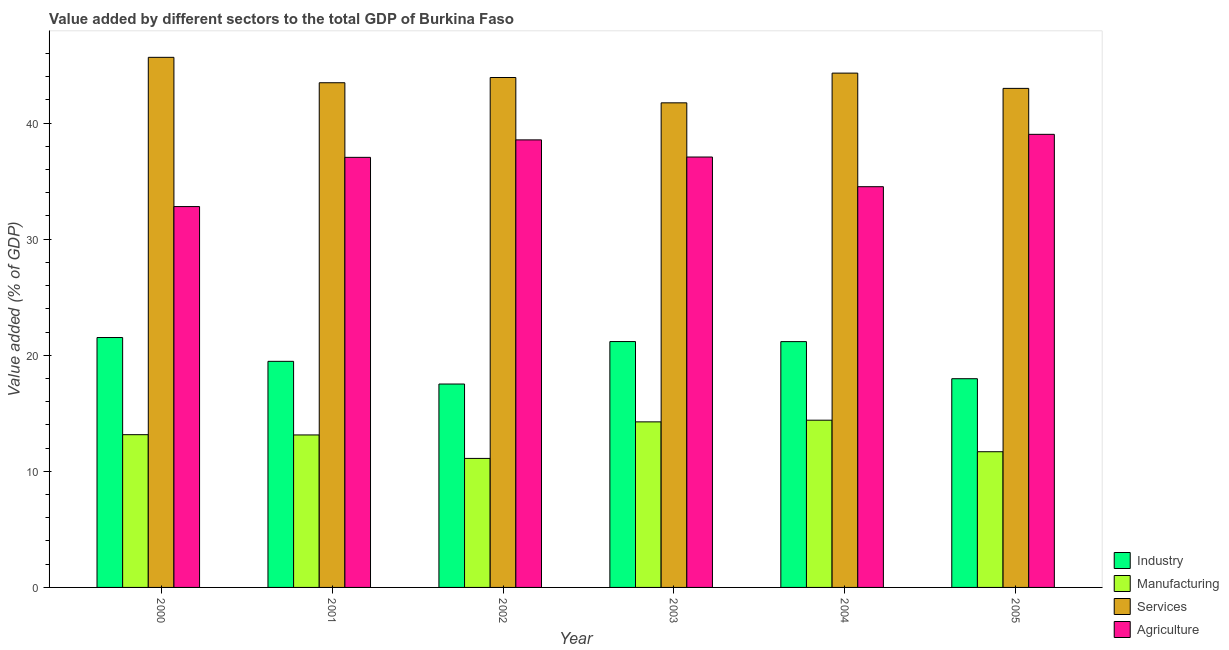Are the number of bars per tick equal to the number of legend labels?
Keep it short and to the point. Yes. How many bars are there on the 2nd tick from the left?
Keep it short and to the point. 4. What is the label of the 3rd group of bars from the left?
Your response must be concise. 2002. What is the value added by industrial sector in 2000?
Provide a short and direct response. 21.53. Across all years, what is the maximum value added by agricultural sector?
Give a very brief answer. 39.03. Across all years, what is the minimum value added by services sector?
Your response must be concise. 41.74. In which year was the value added by manufacturing sector maximum?
Offer a very short reply. 2004. In which year was the value added by services sector minimum?
Your response must be concise. 2003. What is the total value added by manufacturing sector in the graph?
Offer a terse response. 77.76. What is the difference between the value added by manufacturing sector in 2002 and that in 2004?
Give a very brief answer. -3.29. What is the difference between the value added by industrial sector in 2005 and the value added by agricultural sector in 2000?
Your answer should be very brief. -3.55. What is the average value added by agricultural sector per year?
Your response must be concise. 36.51. What is the ratio of the value added by industrial sector in 2004 to that in 2005?
Keep it short and to the point. 1.18. What is the difference between the highest and the second highest value added by industrial sector?
Provide a short and direct response. 0.35. What is the difference between the highest and the lowest value added by services sector?
Your response must be concise. 3.92. In how many years, is the value added by agricultural sector greater than the average value added by agricultural sector taken over all years?
Your answer should be compact. 4. Is the sum of the value added by services sector in 2001 and 2003 greater than the maximum value added by manufacturing sector across all years?
Provide a succinct answer. Yes. Is it the case that in every year, the sum of the value added by services sector and value added by agricultural sector is greater than the sum of value added by manufacturing sector and value added by industrial sector?
Keep it short and to the point. Yes. What does the 1st bar from the left in 2000 represents?
Your answer should be compact. Industry. What does the 1st bar from the right in 2000 represents?
Offer a very short reply. Agriculture. How many bars are there?
Make the answer very short. 24. How many years are there in the graph?
Provide a succinct answer. 6. Does the graph contain any zero values?
Offer a terse response. No. Where does the legend appear in the graph?
Your response must be concise. Bottom right. How many legend labels are there?
Provide a short and direct response. 4. What is the title of the graph?
Provide a succinct answer. Value added by different sectors to the total GDP of Burkina Faso. Does "International Monetary Fund" appear as one of the legend labels in the graph?
Keep it short and to the point. No. What is the label or title of the Y-axis?
Provide a succinct answer. Value added (% of GDP). What is the Value added (% of GDP) of Industry in 2000?
Your response must be concise. 21.53. What is the Value added (% of GDP) of Manufacturing in 2000?
Ensure brevity in your answer.  13.16. What is the Value added (% of GDP) in Services in 2000?
Your response must be concise. 45.66. What is the Value added (% of GDP) in Agriculture in 2000?
Ensure brevity in your answer.  32.81. What is the Value added (% of GDP) of Industry in 2001?
Offer a very short reply. 19.48. What is the Value added (% of GDP) in Manufacturing in 2001?
Keep it short and to the point. 13.13. What is the Value added (% of GDP) of Services in 2001?
Your answer should be compact. 43.47. What is the Value added (% of GDP) in Agriculture in 2001?
Provide a succinct answer. 37.05. What is the Value added (% of GDP) of Industry in 2002?
Offer a terse response. 17.52. What is the Value added (% of GDP) in Manufacturing in 2002?
Ensure brevity in your answer.  11.11. What is the Value added (% of GDP) in Services in 2002?
Offer a very short reply. 43.93. What is the Value added (% of GDP) in Agriculture in 2002?
Provide a succinct answer. 38.55. What is the Value added (% of GDP) of Industry in 2003?
Ensure brevity in your answer.  21.18. What is the Value added (% of GDP) of Manufacturing in 2003?
Offer a terse response. 14.26. What is the Value added (% of GDP) of Services in 2003?
Offer a terse response. 41.74. What is the Value added (% of GDP) of Agriculture in 2003?
Provide a short and direct response. 37.08. What is the Value added (% of GDP) of Industry in 2004?
Provide a short and direct response. 21.18. What is the Value added (% of GDP) in Manufacturing in 2004?
Your answer should be very brief. 14.41. What is the Value added (% of GDP) of Services in 2004?
Give a very brief answer. 44.3. What is the Value added (% of GDP) in Agriculture in 2004?
Your answer should be very brief. 34.52. What is the Value added (% of GDP) of Industry in 2005?
Your answer should be compact. 17.98. What is the Value added (% of GDP) of Manufacturing in 2005?
Your answer should be compact. 11.69. What is the Value added (% of GDP) in Services in 2005?
Your answer should be very brief. 42.99. What is the Value added (% of GDP) in Agriculture in 2005?
Your answer should be compact. 39.03. Across all years, what is the maximum Value added (% of GDP) of Industry?
Provide a short and direct response. 21.53. Across all years, what is the maximum Value added (% of GDP) of Manufacturing?
Ensure brevity in your answer.  14.41. Across all years, what is the maximum Value added (% of GDP) in Services?
Keep it short and to the point. 45.66. Across all years, what is the maximum Value added (% of GDP) in Agriculture?
Offer a very short reply. 39.03. Across all years, what is the minimum Value added (% of GDP) in Industry?
Provide a succinct answer. 17.52. Across all years, what is the minimum Value added (% of GDP) in Manufacturing?
Provide a short and direct response. 11.11. Across all years, what is the minimum Value added (% of GDP) in Services?
Make the answer very short. 41.74. Across all years, what is the minimum Value added (% of GDP) of Agriculture?
Provide a succinct answer. 32.81. What is the total Value added (% of GDP) in Industry in the graph?
Provide a succinct answer. 118.86. What is the total Value added (% of GDP) of Manufacturing in the graph?
Offer a very short reply. 77.76. What is the total Value added (% of GDP) in Services in the graph?
Your answer should be very brief. 262.1. What is the total Value added (% of GDP) in Agriculture in the graph?
Provide a succinct answer. 219.04. What is the difference between the Value added (% of GDP) of Industry in 2000 and that in 2001?
Keep it short and to the point. 2.05. What is the difference between the Value added (% of GDP) in Manufacturing in 2000 and that in 2001?
Keep it short and to the point. 0.02. What is the difference between the Value added (% of GDP) of Services in 2000 and that in 2001?
Your response must be concise. 2.19. What is the difference between the Value added (% of GDP) of Agriculture in 2000 and that in 2001?
Your answer should be very brief. -4.24. What is the difference between the Value added (% of GDP) in Industry in 2000 and that in 2002?
Make the answer very short. 4.01. What is the difference between the Value added (% of GDP) of Manufacturing in 2000 and that in 2002?
Give a very brief answer. 2.05. What is the difference between the Value added (% of GDP) in Services in 2000 and that in 2002?
Offer a terse response. 1.74. What is the difference between the Value added (% of GDP) of Agriculture in 2000 and that in 2002?
Ensure brevity in your answer.  -5.74. What is the difference between the Value added (% of GDP) of Industry in 2000 and that in 2003?
Provide a succinct answer. 0.35. What is the difference between the Value added (% of GDP) in Manufacturing in 2000 and that in 2003?
Offer a terse response. -1.1. What is the difference between the Value added (% of GDP) of Services in 2000 and that in 2003?
Ensure brevity in your answer.  3.92. What is the difference between the Value added (% of GDP) in Agriculture in 2000 and that in 2003?
Offer a terse response. -4.27. What is the difference between the Value added (% of GDP) in Industry in 2000 and that in 2004?
Provide a short and direct response. 0.35. What is the difference between the Value added (% of GDP) in Manufacturing in 2000 and that in 2004?
Your response must be concise. -1.25. What is the difference between the Value added (% of GDP) of Services in 2000 and that in 2004?
Provide a succinct answer. 1.36. What is the difference between the Value added (% of GDP) in Agriculture in 2000 and that in 2004?
Your response must be concise. -1.71. What is the difference between the Value added (% of GDP) in Industry in 2000 and that in 2005?
Provide a succinct answer. 3.55. What is the difference between the Value added (% of GDP) in Manufacturing in 2000 and that in 2005?
Keep it short and to the point. 1.47. What is the difference between the Value added (% of GDP) of Services in 2000 and that in 2005?
Your answer should be compact. 2.67. What is the difference between the Value added (% of GDP) of Agriculture in 2000 and that in 2005?
Make the answer very short. -6.22. What is the difference between the Value added (% of GDP) of Industry in 2001 and that in 2002?
Your response must be concise. 1.95. What is the difference between the Value added (% of GDP) of Manufacturing in 2001 and that in 2002?
Provide a succinct answer. 2.02. What is the difference between the Value added (% of GDP) in Services in 2001 and that in 2002?
Ensure brevity in your answer.  -0.45. What is the difference between the Value added (% of GDP) of Agriculture in 2001 and that in 2002?
Your answer should be very brief. -1.5. What is the difference between the Value added (% of GDP) of Industry in 2001 and that in 2003?
Give a very brief answer. -1.7. What is the difference between the Value added (% of GDP) in Manufacturing in 2001 and that in 2003?
Your answer should be compact. -1.13. What is the difference between the Value added (% of GDP) of Services in 2001 and that in 2003?
Provide a succinct answer. 1.73. What is the difference between the Value added (% of GDP) of Agriculture in 2001 and that in 2003?
Provide a succinct answer. -0.03. What is the difference between the Value added (% of GDP) of Industry in 2001 and that in 2004?
Provide a short and direct response. -1.7. What is the difference between the Value added (% of GDP) of Manufacturing in 2001 and that in 2004?
Offer a very short reply. -1.27. What is the difference between the Value added (% of GDP) in Services in 2001 and that in 2004?
Your response must be concise. -0.83. What is the difference between the Value added (% of GDP) in Agriculture in 2001 and that in 2004?
Provide a succinct answer. 2.53. What is the difference between the Value added (% of GDP) in Industry in 2001 and that in 2005?
Keep it short and to the point. 1.5. What is the difference between the Value added (% of GDP) of Manufacturing in 2001 and that in 2005?
Your answer should be compact. 1.45. What is the difference between the Value added (% of GDP) of Services in 2001 and that in 2005?
Keep it short and to the point. 0.49. What is the difference between the Value added (% of GDP) of Agriculture in 2001 and that in 2005?
Ensure brevity in your answer.  -1.98. What is the difference between the Value added (% of GDP) of Industry in 2002 and that in 2003?
Ensure brevity in your answer.  -3.66. What is the difference between the Value added (% of GDP) in Manufacturing in 2002 and that in 2003?
Provide a short and direct response. -3.15. What is the difference between the Value added (% of GDP) in Services in 2002 and that in 2003?
Offer a very short reply. 2.18. What is the difference between the Value added (% of GDP) in Agriculture in 2002 and that in 2003?
Your response must be concise. 1.48. What is the difference between the Value added (% of GDP) of Industry in 2002 and that in 2004?
Your response must be concise. -3.65. What is the difference between the Value added (% of GDP) of Manufacturing in 2002 and that in 2004?
Ensure brevity in your answer.  -3.29. What is the difference between the Value added (% of GDP) in Services in 2002 and that in 2004?
Your response must be concise. -0.38. What is the difference between the Value added (% of GDP) in Agriculture in 2002 and that in 2004?
Ensure brevity in your answer.  4.03. What is the difference between the Value added (% of GDP) of Industry in 2002 and that in 2005?
Make the answer very short. -0.46. What is the difference between the Value added (% of GDP) of Manufacturing in 2002 and that in 2005?
Keep it short and to the point. -0.58. What is the difference between the Value added (% of GDP) in Services in 2002 and that in 2005?
Give a very brief answer. 0.94. What is the difference between the Value added (% of GDP) in Agriculture in 2002 and that in 2005?
Keep it short and to the point. -0.48. What is the difference between the Value added (% of GDP) of Industry in 2003 and that in 2004?
Make the answer very short. 0.01. What is the difference between the Value added (% of GDP) in Manufacturing in 2003 and that in 2004?
Your answer should be compact. -0.14. What is the difference between the Value added (% of GDP) of Services in 2003 and that in 2004?
Ensure brevity in your answer.  -2.56. What is the difference between the Value added (% of GDP) of Agriculture in 2003 and that in 2004?
Keep it short and to the point. 2.56. What is the difference between the Value added (% of GDP) of Industry in 2003 and that in 2005?
Ensure brevity in your answer.  3.2. What is the difference between the Value added (% of GDP) in Manufacturing in 2003 and that in 2005?
Provide a succinct answer. 2.57. What is the difference between the Value added (% of GDP) in Services in 2003 and that in 2005?
Provide a short and direct response. -1.25. What is the difference between the Value added (% of GDP) of Agriculture in 2003 and that in 2005?
Give a very brief answer. -1.96. What is the difference between the Value added (% of GDP) in Industry in 2004 and that in 2005?
Provide a short and direct response. 3.2. What is the difference between the Value added (% of GDP) in Manufacturing in 2004 and that in 2005?
Your response must be concise. 2.72. What is the difference between the Value added (% of GDP) in Services in 2004 and that in 2005?
Offer a very short reply. 1.31. What is the difference between the Value added (% of GDP) of Agriculture in 2004 and that in 2005?
Your answer should be very brief. -4.51. What is the difference between the Value added (% of GDP) of Industry in 2000 and the Value added (% of GDP) of Manufacturing in 2001?
Keep it short and to the point. 8.39. What is the difference between the Value added (% of GDP) in Industry in 2000 and the Value added (% of GDP) in Services in 2001?
Provide a succinct answer. -21.95. What is the difference between the Value added (% of GDP) of Industry in 2000 and the Value added (% of GDP) of Agriculture in 2001?
Offer a very short reply. -15.52. What is the difference between the Value added (% of GDP) in Manufacturing in 2000 and the Value added (% of GDP) in Services in 2001?
Give a very brief answer. -30.32. What is the difference between the Value added (% of GDP) of Manufacturing in 2000 and the Value added (% of GDP) of Agriculture in 2001?
Provide a succinct answer. -23.89. What is the difference between the Value added (% of GDP) of Services in 2000 and the Value added (% of GDP) of Agriculture in 2001?
Provide a succinct answer. 8.62. What is the difference between the Value added (% of GDP) in Industry in 2000 and the Value added (% of GDP) in Manufacturing in 2002?
Offer a terse response. 10.41. What is the difference between the Value added (% of GDP) in Industry in 2000 and the Value added (% of GDP) in Services in 2002?
Give a very brief answer. -22.4. What is the difference between the Value added (% of GDP) of Industry in 2000 and the Value added (% of GDP) of Agriculture in 2002?
Offer a terse response. -17.03. What is the difference between the Value added (% of GDP) of Manufacturing in 2000 and the Value added (% of GDP) of Services in 2002?
Your answer should be compact. -30.77. What is the difference between the Value added (% of GDP) in Manufacturing in 2000 and the Value added (% of GDP) in Agriculture in 2002?
Provide a short and direct response. -25.39. What is the difference between the Value added (% of GDP) of Services in 2000 and the Value added (% of GDP) of Agriculture in 2002?
Your answer should be compact. 7.11. What is the difference between the Value added (% of GDP) of Industry in 2000 and the Value added (% of GDP) of Manufacturing in 2003?
Keep it short and to the point. 7.27. What is the difference between the Value added (% of GDP) in Industry in 2000 and the Value added (% of GDP) in Services in 2003?
Provide a short and direct response. -20.22. What is the difference between the Value added (% of GDP) of Industry in 2000 and the Value added (% of GDP) of Agriculture in 2003?
Provide a short and direct response. -15.55. What is the difference between the Value added (% of GDP) of Manufacturing in 2000 and the Value added (% of GDP) of Services in 2003?
Keep it short and to the point. -28.59. What is the difference between the Value added (% of GDP) in Manufacturing in 2000 and the Value added (% of GDP) in Agriculture in 2003?
Offer a very short reply. -23.92. What is the difference between the Value added (% of GDP) of Services in 2000 and the Value added (% of GDP) of Agriculture in 2003?
Ensure brevity in your answer.  8.59. What is the difference between the Value added (% of GDP) of Industry in 2000 and the Value added (% of GDP) of Manufacturing in 2004?
Provide a short and direct response. 7.12. What is the difference between the Value added (% of GDP) in Industry in 2000 and the Value added (% of GDP) in Services in 2004?
Give a very brief answer. -22.78. What is the difference between the Value added (% of GDP) of Industry in 2000 and the Value added (% of GDP) of Agriculture in 2004?
Your response must be concise. -12.99. What is the difference between the Value added (% of GDP) in Manufacturing in 2000 and the Value added (% of GDP) in Services in 2004?
Provide a succinct answer. -31.15. What is the difference between the Value added (% of GDP) of Manufacturing in 2000 and the Value added (% of GDP) of Agriculture in 2004?
Ensure brevity in your answer.  -21.36. What is the difference between the Value added (% of GDP) of Services in 2000 and the Value added (% of GDP) of Agriculture in 2004?
Ensure brevity in your answer.  11.14. What is the difference between the Value added (% of GDP) in Industry in 2000 and the Value added (% of GDP) in Manufacturing in 2005?
Ensure brevity in your answer.  9.84. What is the difference between the Value added (% of GDP) in Industry in 2000 and the Value added (% of GDP) in Services in 2005?
Your answer should be compact. -21.46. What is the difference between the Value added (% of GDP) of Industry in 2000 and the Value added (% of GDP) of Agriculture in 2005?
Provide a succinct answer. -17.5. What is the difference between the Value added (% of GDP) of Manufacturing in 2000 and the Value added (% of GDP) of Services in 2005?
Offer a very short reply. -29.83. What is the difference between the Value added (% of GDP) of Manufacturing in 2000 and the Value added (% of GDP) of Agriculture in 2005?
Provide a short and direct response. -25.87. What is the difference between the Value added (% of GDP) in Services in 2000 and the Value added (% of GDP) in Agriculture in 2005?
Your response must be concise. 6.63. What is the difference between the Value added (% of GDP) in Industry in 2001 and the Value added (% of GDP) in Manufacturing in 2002?
Provide a short and direct response. 8.36. What is the difference between the Value added (% of GDP) of Industry in 2001 and the Value added (% of GDP) of Services in 2002?
Make the answer very short. -24.45. What is the difference between the Value added (% of GDP) of Industry in 2001 and the Value added (% of GDP) of Agriculture in 2002?
Provide a succinct answer. -19.08. What is the difference between the Value added (% of GDP) in Manufacturing in 2001 and the Value added (% of GDP) in Services in 2002?
Provide a succinct answer. -30.79. What is the difference between the Value added (% of GDP) of Manufacturing in 2001 and the Value added (% of GDP) of Agriculture in 2002?
Provide a succinct answer. -25.42. What is the difference between the Value added (% of GDP) in Services in 2001 and the Value added (% of GDP) in Agriculture in 2002?
Your response must be concise. 4.92. What is the difference between the Value added (% of GDP) in Industry in 2001 and the Value added (% of GDP) in Manufacturing in 2003?
Ensure brevity in your answer.  5.21. What is the difference between the Value added (% of GDP) in Industry in 2001 and the Value added (% of GDP) in Services in 2003?
Offer a very short reply. -22.27. What is the difference between the Value added (% of GDP) of Industry in 2001 and the Value added (% of GDP) of Agriculture in 2003?
Offer a terse response. -17.6. What is the difference between the Value added (% of GDP) of Manufacturing in 2001 and the Value added (% of GDP) of Services in 2003?
Your answer should be very brief. -28.61. What is the difference between the Value added (% of GDP) in Manufacturing in 2001 and the Value added (% of GDP) in Agriculture in 2003?
Ensure brevity in your answer.  -23.94. What is the difference between the Value added (% of GDP) of Services in 2001 and the Value added (% of GDP) of Agriculture in 2003?
Ensure brevity in your answer.  6.4. What is the difference between the Value added (% of GDP) of Industry in 2001 and the Value added (% of GDP) of Manufacturing in 2004?
Offer a terse response. 5.07. What is the difference between the Value added (% of GDP) in Industry in 2001 and the Value added (% of GDP) in Services in 2004?
Your answer should be compact. -24.83. What is the difference between the Value added (% of GDP) of Industry in 2001 and the Value added (% of GDP) of Agriculture in 2004?
Make the answer very short. -15.04. What is the difference between the Value added (% of GDP) in Manufacturing in 2001 and the Value added (% of GDP) in Services in 2004?
Provide a short and direct response. -31.17. What is the difference between the Value added (% of GDP) in Manufacturing in 2001 and the Value added (% of GDP) in Agriculture in 2004?
Provide a succinct answer. -21.39. What is the difference between the Value added (% of GDP) of Services in 2001 and the Value added (% of GDP) of Agriculture in 2004?
Offer a terse response. 8.95. What is the difference between the Value added (% of GDP) of Industry in 2001 and the Value added (% of GDP) of Manufacturing in 2005?
Make the answer very short. 7.79. What is the difference between the Value added (% of GDP) in Industry in 2001 and the Value added (% of GDP) in Services in 2005?
Give a very brief answer. -23.51. What is the difference between the Value added (% of GDP) in Industry in 2001 and the Value added (% of GDP) in Agriculture in 2005?
Your answer should be compact. -19.55. What is the difference between the Value added (% of GDP) of Manufacturing in 2001 and the Value added (% of GDP) of Services in 2005?
Provide a short and direct response. -29.85. What is the difference between the Value added (% of GDP) in Manufacturing in 2001 and the Value added (% of GDP) in Agriculture in 2005?
Your response must be concise. -25.9. What is the difference between the Value added (% of GDP) in Services in 2001 and the Value added (% of GDP) in Agriculture in 2005?
Your response must be concise. 4.44. What is the difference between the Value added (% of GDP) in Industry in 2002 and the Value added (% of GDP) in Manufacturing in 2003?
Provide a succinct answer. 3.26. What is the difference between the Value added (% of GDP) in Industry in 2002 and the Value added (% of GDP) in Services in 2003?
Make the answer very short. -24.22. What is the difference between the Value added (% of GDP) of Industry in 2002 and the Value added (% of GDP) of Agriculture in 2003?
Provide a succinct answer. -19.55. What is the difference between the Value added (% of GDP) of Manufacturing in 2002 and the Value added (% of GDP) of Services in 2003?
Your answer should be compact. -30.63. What is the difference between the Value added (% of GDP) in Manufacturing in 2002 and the Value added (% of GDP) in Agriculture in 2003?
Keep it short and to the point. -25.96. What is the difference between the Value added (% of GDP) in Services in 2002 and the Value added (% of GDP) in Agriculture in 2003?
Provide a short and direct response. 6.85. What is the difference between the Value added (% of GDP) in Industry in 2002 and the Value added (% of GDP) in Manufacturing in 2004?
Offer a very short reply. 3.12. What is the difference between the Value added (% of GDP) in Industry in 2002 and the Value added (% of GDP) in Services in 2004?
Provide a short and direct response. -26.78. What is the difference between the Value added (% of GDP) in Industry in 2002 and the Value added (% of GDP) in Agriculture in 2004?
Your answer should be very brief. -17. What is the difference between the Value added (% of GDP) in Manufacturing in 2002 and the Value added (% of GDP) in Services in 2004?
Offer a very short reply. -33.19. What is the difference between the Value added (% of GDP) of Manufacturing in 2002 and the Value added (% of GDP) of Agriculture in 2004?
Keep it short and to the point. -23.41. What is the difference between the Value added (% of GDP) of Services in 2002 and the Value added (% of GDP) of Agriculture in 2004?
Your answer should be compact. 9.4. What is the difference between the Value added (% of GDP) of Industry in 2002 and the Value added (% of GDP) of Manufacturing in 2005?
Keep it short and to the point. 5.83. What is the difference between the Value added (% of GDP) of Industry in 2002 and the Value added (% of GDP) of Services in 2005?
Give a very brief answer. -25.47. What is the difference between the Value added (% of GDP) of Industry in 2002 and the Value added (% of GDP) of Agriculture in 2005?
Provide a short and direct response. -21.51. What is the difference between the Value added (% of GDP) of Manufacturing in 2002 and the Value added (% of GDP) of Services in 2005?
Make the answer very short. -31.88. What is the difference between the Value added (% of GDP) in Manufacturing in 2002 and the Value added (% of GDP) in Agriculture in 2005?
Give a very brief answer. -27.92. What is the difference between the Value added (% of GDP) of Services in 2002 and the Value added (% of GDP) of Agriculture in 2005?
Give a very brief answer. 4.89. What is the difference between the Value added (% of GDP) of Industry in 2003 and the Value added (% of GDP) of Manufacturing in 2004?
Provide a succinct answer. 6.77. What is the difference between the Value added (% of GDP) in Industry in 2003 and the Value added (% of GDP) in Services in 2004?
Offer a terse response. -23.12. What is the difference between the Value added (% of GDP) in Industry in 2003 and the Value added (% of GDP) in Agriculture in 2004?
Keep it short and to the point. -13.34. What is the difference between the Value added (% of GDP) of Manufacturing in 2003 and the Value added (% of GDP) of Services in 2004?
Offer a very short reply. -30.04. What is the difference between the Value added (% of GDP) of Manufacturing in 2003 and the Value added (% of GDP) of Agriculture in 2004?
Give a very brief answer. -20.26. What is the difference between the Value added (% of GDP) of Services in 2003 and the Value added (% of GDP) of Agriculture in 2004?
Your answer should be very brief. 7.22. What is the difference between the Value added (% of GDP) in Industry in 2003 and the Value added (% of GDP) in Manufacturing in 2005?
Make the answer very short. 9.49. What is the difference between the Value added (% of GDP) of Industry in 2003 and the Value added (% of GDP) of Services in 2005?
Your response must be concise. -21.81. What is the difference between the Value added (% of GDP) of Industry in 2003 and the Value added (% of GDP) of Agriculture in 2005?
Your response must be concise. -17.85. What is the difference between the Value added (% of GDP) in Manufacturing in 2003 and the Value added (% of GDP) in Services in 2005?
Your answer should be compact. -28.73. What is the difference between the Value added (% of GDP) in Manufacturing in 2003 and the Value added (% of GDP) in Agriculture in 2005?
Keep it short and to the point. -24.77. What is the difference between the Value added (% of GDP) of Services in 2003 and the Value added (% of GDP) of Agriculture in 2005?
Make the answer very short. 2.71. What is the difference between the Value added (% of GDP) of Industry in 2004 and the Value added (% of GDP) of Manufacturing in 2005?
Give a very brief answer. 9.49. What is the difference between the Value added (% of GDP) of Industry in 2004 and the Value added (% of GDP) of Services in 2005?
Keep it short and to the point. -21.81. What is the difference between the Value added (% of GDP) of Industry in 2004 and the Value added (% of GDP) of Agriculture in 2005?
Your answer should be compact. -17.86. What is the difference between the Value added (% of GDP) of Manufacturing in 2004 and the Value added (% of GDP) of Services in 2005?
Offer a terse response. -28.58. What is the difference between the Value added (% of GDP) of Manufacturing in 2004 and the Value added (% of GDP) of Agriculture in 2005?
Keep it short and to the point. -24.62. What is the difference between the Value added (% of GDP) of Services in 2004 and the Value added (% of GDP) of Agriculture in 2005?
Your answer should be compact. 5.27. What is the average Value added (% of GDP) in Industry per year?
Make the answer very short. 19.81. What is the average Value added (% of GDP) in Manufacturing per year?
Offer a terse response. 12.96. What is the average Value added (% of GDP) of Services per year?
Your response must be concise. 43.68. What is the average Value added (% of GDP) in Agriculture per year?
Offer a very short reply. 36.51. In the year 2000, what is the difference between the Value added (% of GDP) in Industry and Value added (% of GDP) in Manufacturing?
Make the answer very short. 8.37. In the year 2000, what is the difference between the Value added (% of GDP) in Industry and Value added (% of GDP) in Services?
Your answer should be very brief. -24.14. In the year 2000, what is the difference between the Value added (% of GDP) of Industry and Value added (% of GDP) of Agriculture?
Offer a very short reply. -11.28. In the year 2000, what is the difference between the Value added (% of GDP) in Manufacturing and Value added (% of GDP) in Services?
Give a very brief answer. -32.51. In the year 2000, what is the difference between the Value added (% of GDP) in Manufacturing and Value added (% of GDP) in Agriculture?
Your response must be concise. -19.65. In the year 2000, what is the difference between the Value added (% of GDP) in Services and Value added (% of GDP) in Agriculture?
Offer a terse response. 12.86. In the year 2001, what is the difference between the Value added (% of GDP) of Industry and Value added (% of GDP) of Manufacturing?
Your response must be concise. 6.34. In the year 2001, what is the difference between the Value added (% of GDP) of Industry and Value added (% of GDP) of Services?
Provide a short and direct response. -24. In the year 2001, what is the difference between the Value added (% of GDP) of Industry and Value added (% of GDP) of Agriculture?
Provide a short and direct response. -17.57. In the year 2001, what is the difference between the Value added (% of GDP) of Manufacturing and Value added (% of GDP) of Services?
Ensure brevity in your answer.  -30.34. In the year 2001, what is the difference between the Value added (% of GDP) in Manufacturing and Value added (% of GDP) in Agriculture?
Provide a short and direct response. -23.91. In the year 2001, what is the difference between the Value added (% of GDP) in Services and Value added (% of GDP) in Agriculture?
Give a very brief answer. 6.43. In the year 2002, what is the difference between the Value added (% of GDP) of Industry and Value added (% of GDP) of Manufacturing?
Offer a very short reply. 6.41. In the year 2002, what is the difference between the Value added (% of GDP) of Industry and Value added (% of GDP) of Services?
Keep it short and to the point. -26.4. In the year 2002, what is the difference between the Value added (% of GDP) in Industry and Value added (% of GDP) in Agriculture?
Offer a terse response. -21.03. In the year 2002, what is the difference between the Value added (% of GDP) in Manufacturing and Value added (% of GDP) in Services?
Make the answer very short. -32.81. In the year 2002, what is the difference between the Value added (% of GDP) in Manufacturing and Value added (% of GDP) in Agriculture?
Provide a succinct answer. -27.44. In the year 2002, what is the difference between the Value added (% of GDP) of Services and Value added (% of GDP) of Agriculture?
Provide a short and direct response. 5.37. In the year 2003, what is the difference between the Value added (% of GDP) in Industry and Value added (% of GDP) in Manufacturing?
Give a very brief answer. 6.92. In the year 2003, what is the difference between the Value added (% of GDP) in Industry and Value added (% of GDP) in Services?
Offer a terse response. -20.56. In the year 2003, what is the difference between the Value added (% of GDP) in Industry and Value added (% of GDP) in Agriculture?
Provide a succinct answer. -15.9. In the year 2003, what is the difference between the Value added (% of GDP) of Manufacturing and Value added (% of GDP) of Services?
Your answer should be compact. -27.48. In the year 2003, what is the difference between the Value added (% of GDP) of Manufacturing and Value added (% of GDP) of Agriculture?
Provide a short and direct response. -22.81. In the year 2003, what is the difference between the Value added (% of GDP) of Services and Value added (% of GDP) of Agriculture?
Your answer should be very brief. 4.67. In the year 2004, what is the difference between the Value added (% of GDP) of Industry and Value added (% of GDP) of Manufacturing?
Your answer should be compact. 6.77. In the year 2004, what is the difference between the Value added (% of GDP) of Industry and Value added (% of GDP) of Services?
Your response must be concise. -23.13. In the year 2004, what is the difference between the Value added (% of GDP) of Industry and Value added (% of GDP) of Agriculture?
Your response must be concise. -13.35. In the year 2004, what is the difference between the Value added (% of GDP) in Manufacturing and Value added (% of GDP) in Services?
Keep it short and to the point. -29.9. In the year 2004, what is the difference between the Value added (% of GDP) in Manufacturing and Value added (% of GDP) in Agriculture?
Provide a short and direct response. -20.11. In the year 2004, what is the difference between the Value added (% of GDP) of Services and Value added (% of GDP) of Agriculture?
Provide a short and direct response. 9.78. In the year 2005, what is the difference between the Value added (% of GDP) of Industry and Value added (% of GDP) of Manufacturing?
Offer a very short reply. 6.29. In the year 2005, what is the difference between the Value added (% of GDP) of Industry and Value added (% of GDP) of Services?
Make the answer very short. -25.01. In the year 2005, what is the difference between the Value added (% of GDP) of Industry and Value added (% of GDP) of Agriculture?
Your response must be concise. -21.05. In the year 2005, what is the difference between the Value added (% of GDP) in Manufacturing and Value added (% of GDP) in Services?
Your response must be concise. -31.3. In the year 2005, what is the difference between the Value added (% of GDP) of Manufacturing and Value added (% of GDP) of Agriculture?
Your answer should be very brief. -27.34. In the year 2005, what is the difference between the Value added (% of GDP) in Services and Value added (% of GDP) in Agriculture?
Your answer should be compact. 3.96. What is the ratio of the Value added (% of GDP) of Industry in 2000 to that in 2001?
Offer a very short reply. 1.11. What is the ratio of the Value added (% of GDP) in Services in 2000 to that in 2001?
Provide a succinct answer. 1.05. What is the ratio of the Value added (% of GDP) of Agriculture in 2000 to that in 2001?
Make the answer very short. 0.89. What is the ratio of the Value added (% of GDP) in Industry in 2000 to that in 2002?
Your response must be concise. 1.23. What is the ratio of the Value added (% of GDP) in Manufacturing in 2000 to that in 2002?
Ensure brevity in your answer.  1.18. What is the ratio of the Value added (% of GDP) in Services in 2000 to that in 2002?
Make the answer very short. 1.04. What is the ratio of the Value added (% of GDP) of Agriculture in 2000 to that in 2002?
Ensure brevity in your answer.  0.85. What is the ratio of the Value added (% of GDP) of Industry in 2000 to that in 2003?
Offer a very short reply. 1.02. What is the ratio of the Value added (% of GDP) of Manufacturing in 2000 to that in 2003?
Provide a short and direct response. 0.92. What is the ratio of the Value added (% of GDP) of Services in 2000 to that in 2003?
Your response must be concise. 1.09. What is the ratio of the Value added (% of GDP) of Agriculture in 2000 to that in 2003?
Ensure brevity in your answer.  0.88. What is the ratio of the Value added (% of GDP) in Industry in 2000 to that in 2004?
Keep it short and to the point. 1.02. What is the ratio of the Value added (% of GDP) in Manufacturing in 2000 to that in 2004?
Your answer should be very brief. 0.91. What is the ratio of the Value added (% of GDP) in Services in 2000 to that in 2004?
Your response must be concise. 1.03. What is the ratio of the Value added (% of GDP) in Agriculture in 2000 to that in 2004?
Your answer should be very brief. 0.95. What is the ratio of the Value added (% of GDP) of Industry in 2000 to that in 2005?
Provide a succinct answer. 1.2. What is the ratio of the Value added (% of GDP) of Manufacturing in 2000 to that in 2005?
Offer a terse response. 1.13. What is the ratio of the Value added (% of GDP) in Services in 2000 to that in 2005?
Provide a succinct answer. 1.06. What is the ratio of the Value added (% of GDP) of Agriculture in 2000 to that in 2005?
Provide a succinct answer. 0.84. What is the ratio of the Value added (% of GDP) in Industry in 2001 to that in 2002?
Your answer should be very brief. 1.11. What is the ratio of the Value added (% of GDP) in Manufacturing in 2001 to that in 2002?
Provide a succinct answer. 1.18. What is the ratio of the Value added (% of GDP) of Agriculture in 2001 to that in 2002?
Your answer should be compact. 0.96. What is the ratio of the Value added (% of GDP) in Industry in 2001 to that in 2003?
Make the answer very short. 0.92. What is the ratio of the Value added (% of GDP) in Manufacturing in 2001 to that in 2003?
Provide a short and direct response. 0.92. What is the ratio of the Value added (% of GDP) in Services in 2001 to that in 2003?
Offer a terse response. 1.04. What is the ratio of the Value added (% of GDP) in Agriculture in 2001 to that in 2003?
Your answer should be very brief. 1. What is the ratio of the Value added (% of GDP) in Industry in 2001 to that in 2004?
Your answer should be compact. 0.92. What is the ratio of the Value added (% of GDP) of Manufacturing in 2001 to that in 2004?
Offer a very short reply. 0.91. What is the ratio of the Value added (% of GDP) in Services in 2001 to that in 2004?
Your answer should be compact. 0.98. What is the ratio of the Value added (% of GDP) in Agriculture in 2001 to that in 2004?
Ensure brevity in your answer.  1.07. What is the ratio of the Value added (% of GDP) in Industry in 2001 to that in 2005?
Your answer should be very brief. 1.08. What is the ratio of the Value added (% of GDP) in Manufacturing in 2001 to that in 2005?
Your response must be concise. 1.12. What is the ratio of the Value added (% of GDP) in Services in 2001 to that in 2005?
Offer a very short reply. 1.01. What is the ratio of the Value added (% of GDP) in Agriculture in 2001 to that in 2005?
Offer a terse response. 0.95. What is the ratio of the Value added (% of GDP) of Industry in 2002 to that in 2003?
Give a very brief answer. 0.83. What is the ratio of the Value added (% of GDP) in Manufacturing in 2002 to that in 2003?
Offer a terse response. 0.78. What is the ratio of the Value added (% of GDP) of Services in 2002 to that in 2003?
Your answer should be very brief. 1.05. What is the ratio of the Value added (% of GDP) of Agriculture in 2002 to that in 2003?
Offer a very short reply. 1.04. What is the ratio of the Value added (% of GDP) in Industry in 2002 to that in 2004?
Provide a short and direct response. 0.83. What is the ratio of the Value added (% of GDP) in Manufacturing in 2002 to that in 2004?
Give a very brief answer. 0.77. What is the ratio of the Value added (% of GDP) of Services in 2002 to that in 2004?
Provide a short and direct response. 0.99. What is the ratio of the Value added (% of GDP) of Agriculture in 2002 to that in 2004?
Keep it short and to the point. 1.12. What is the ratio of the Value added (% of GDP) of Industry in 2002 to that in 2005?
Your response must be concise. 0.97. What is the ratio of the Value added (% of GDP) of Manufacturing in 2002 to that in 2005?
Provide a succinct answer. 0.95. What is the ratio of the Value added (% of GDP) of Services in 2002 to that in 2005?
Keep it short and to the point. 1.02. What is the ratio of the Value added (% of GDP) of Agriculture in 2002 to that in 2005?
Your response must be concise. 0.99. What is the ratio of the Value added (% of GDP) of Manufacturing in 2003 to that in 2004?
Keep it short and to the point. 0.99. What is the ratio of the Value added (% of GDP) of Services in 2003 to that in 2004?
Offer a terse response. 0.94. What is the ratio of the Value added (% of GDP) in Agriculture in 2003 to that in 2004?
Give a very brief answer. 1.07. What is the ratio of the Value added (% of GDP) of Industry in 2003 to that in 2005?
Your answer should be very brief. 1.18. What is the ratio of the Value added (% of GDP) in Manufacturing in 2003 to that in 2005?
Offer a very short reply. 1.22. What is the ratio of the Value added (% of GDP) in Services in 2003 to that in 2005?
Provide a succinct answer. 0.97. What is the ratio of the Value added (% of GDP) of Agriculture in 2003 to that in 2005?
Your response must be concise. 0.95. What is the ratio of the Value added (% of GDP) of Industry in 2004 to that in 2005?
Ensure brevity in your answer.  1.18. What is the ratio of the Value added (% of GDP) in Manufacturing in 2004 to that in 2005?
Your response must be concise. 1.23. What is the ratio of the Value added (% of GDP) of Services in 2004 to that in 2005?
Provide a short and direct response. 1.03. What is the ratio of the Value added (% of GDP) of Agriculture in 2004 to that in 2005?
Offer a very short reply. 0.88. What is the difference between the highest and the second highest Value added (% of GDP) of Industry?
Your response must be concise. 0.35. What is the difference between the highest and the second highest Value added (% of GDP) of Manufacturing?
Your response must be concise. 0.14. What is the difference between the highest and the second highest Value added (% of GDP) of Services?
Provide a short and direct response. 1.36. What is the difference between the highest and the second highest Value added (% of GDP) of Agriculture?
Provide a succinct answer. 0.48. What is the difference between the highest and the lowest Value added (% of GDP) of Industry?
Give a very brief answer. 4.01. What is the difference between the highest and the lowest Value added (% of GDP) in Manufacturing?
Ensure brevity in your answer.  3.29. What is the difference between the highest and the lowest Value added (% of GDP) of Services?
Offer a terse response. 3.92. What is the difference between the highest and the lowest Value added (% of GDP) of Agriculture?
Your response must be concise. 6.22. 